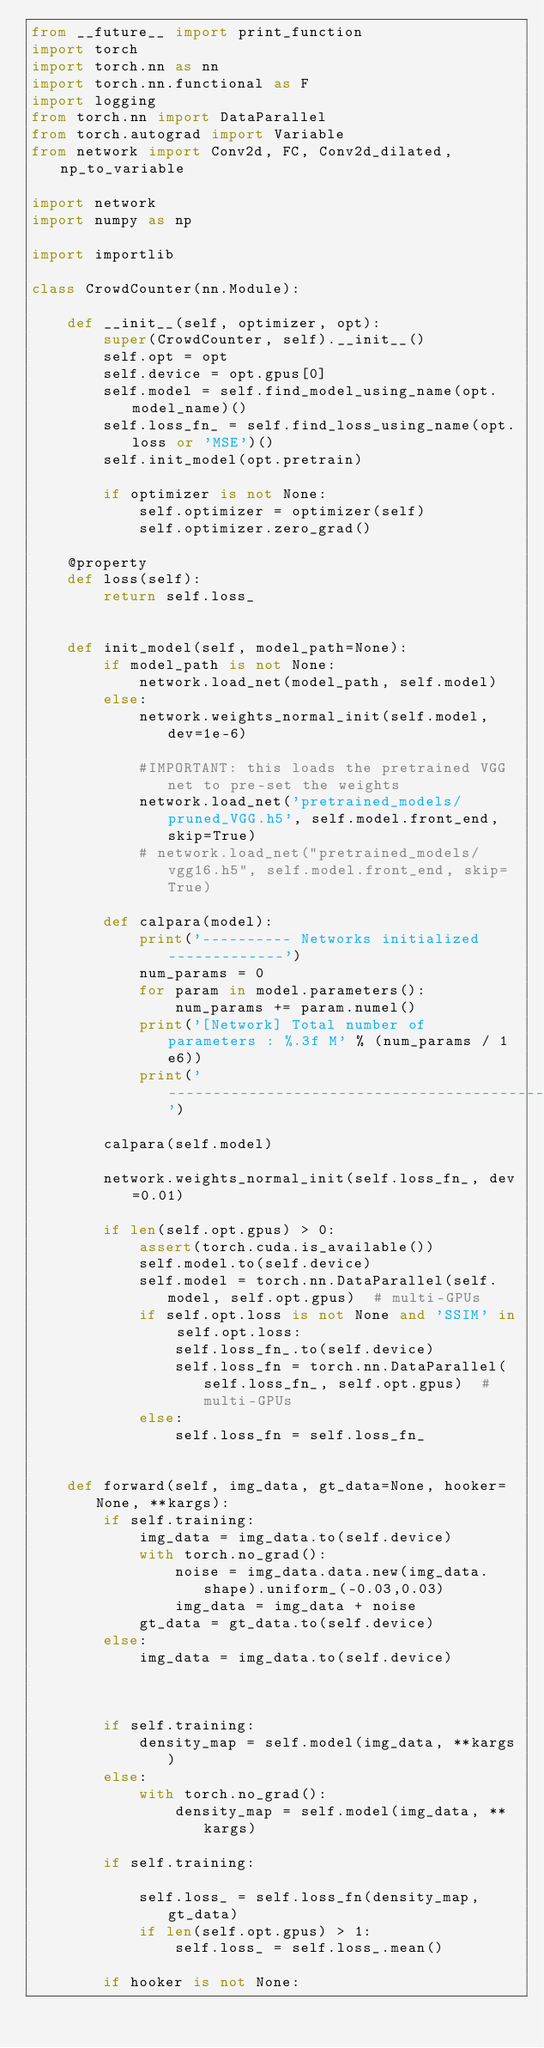<code> <loc_0><loc_0><loc_500><loc_500><_Python_>from __future__ import print_function
import torch
import torch.nn as nn
import torch.nn.functional as F
import logging
from torch.nn import DataParallel
from torch.autograd import Variable
from network import Conv2d, FC, Conv2d_dilated, np_to_variable

import network
import numpy as np

import importlib

class CrowdCounter(nn.Module):

    def __init__(self, optimizer, opt):
        super(CrowdCounter, self).__init__()
        self.opt = opt
        self.device = opt.gpus[0]
        self.model = self.find_model_using_name(opt.model_name)()
        self.loss_fn_ = self.find_loss_using_name(opt.loss or 'MSE')()
        self.init_model(opt.pretrain)

        if optimizer is not None:
            self.optimizer = optimizer(self)
            self.optimizer.zero_grad()

    @property
    def loss(self):
        return self.loss_ 


    def init_model(self, model_path=None):
        if model_path is not None:
            network.load_net(model_path, self.model)
        else:
            network.weights_normal_init(self.model, dev=1e-6)

            #IMPORTANT: this loads the pretrained VGG net to pre-set the weights
            network.load_net('pretrained_models/pruned_VGG.h5', self.model.front_end, skip=True)
            # network.load_net("pretrained_models/vgg16.h5", self.model.front_end, skip=True)

        def calpara(model):
            print('---------- Networks initialized -------------')
            num_params = 0
            for param in model.parameters():
                num_params += param.numel()
            print('[Network] Total number of parameters : %.3f M' % (num_params / 1e6))
            print('-----------------------------------------------')

        calpara(self.model)

        network.weights_normal_init(self.loss_fn_, dev=0.01)

        if len(self.opt.gpus) > 0:
            assert(torch.cuda.is_available())
            self.model.to(self.device)
            self.model = torch.nn.DataParallel(self.model, self.opt.gpus)  # multi-GPUs
            if self.opt.loss is not None and 'SSIM' in self.opt.loss:
                self.loss_fn_.to(self.device)
                self.loss_fn = torch.nn.DataParallel(self.loss_fn_, self.opt.gpus)  # multi-GPUs
            else:
                self.loss_fn = self.loss_fn_

    
    def forward(self, img_data, gt_data=None, hooker=None, **kargs):
        if self.training:
            img_data = img_data.to(self.device)
            with torch.no_grad():
                noise = img_data.data.new(img_data.shape).uniform_(-0.03,0.03)
                img_data = img_data + noise
            gt_data = gt_data.to(self.device)
        else:
            img_data = img_data.to(self.device)
              


        if self.training:
            density_map = self.model(img_data, **kargs)
        else:
            with torch.no_grad():
                density_map = self.model(img_data, **kargs)

        if self.training:

            self.loss_ = self.loss_fn(density_map, gt_data)
            if len(self.opt.gpus) > 1:
                self.loss_ = self.loss_.mean()

        if hooker is not None:</code> 